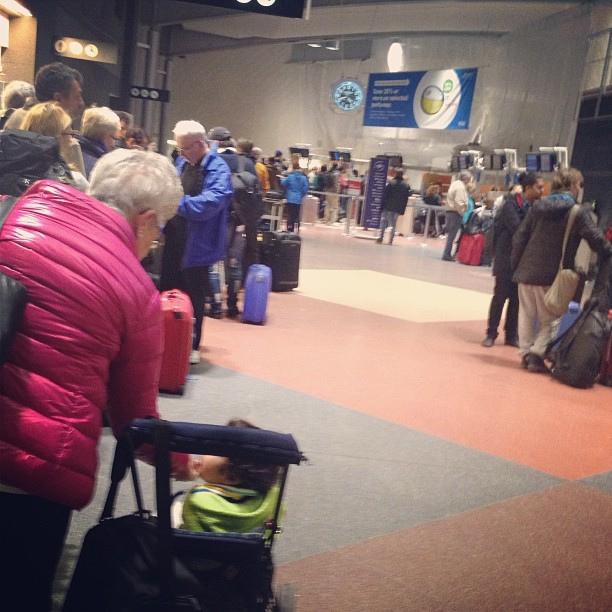What are the people standing with?
Give a very brief answer. Luggage. Who has the most luggage?
Concise answer only. Woman. Do you see a purple suitcase?
Keep it brief. Yes. Is this an airport?
Be succinct. Yes. 